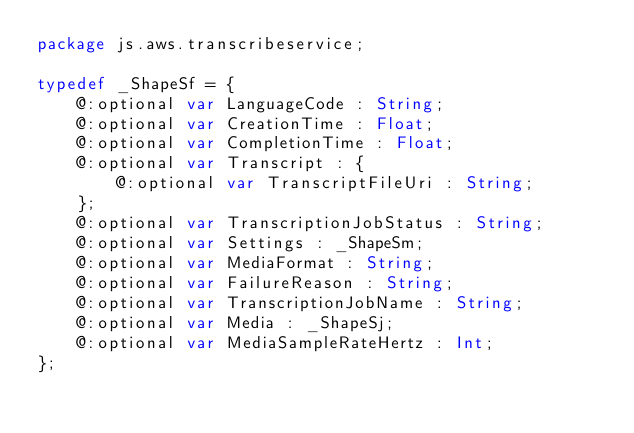<code> <loc_0><loc_0><loc_500><loc_500><_Haxe_>package js.aws.transcribeservice;

typedef _ShapeSf = {
    @:optional var LanguageCode : String;
    @:optional var CreationTime : Float;
    @:optional var CompletionTime : Float;
    @:optional var Transcript : {
        @:optional var TranscriptFileUri : String;
    };
    @:optional var TranscriptionJobStatus : String;
    @:optional var Settings : _ShapeSm;
    @:optional var MediaFormat : String;
    @:optional var FailureReason : String;
    @:optional var TranscriptionJobName : String;
    @:optional var Media : _ShapeSj;
    @:optional var MediaSampleRateHertz : Int;
};
</code> 